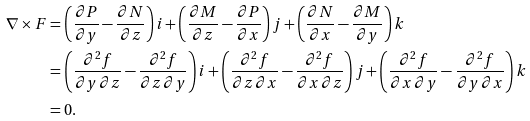<formula> <loc_0><loc_0><loc_500><loc_500>\nabla \times F & = \left ( \frac { \partial P } { \partial y } - \frac { \partial N } { \partial z } \right ) i + \left ( \frac { \partial M } { \partial z } - \frac { \partial P } { \partial x } \right ) j + \left ( \frac { \partial N } { \partial x } - \frac { \partial M } { \partial y } \right ) k \\ & = \left ( \frac { \partial ^ { 2 } f } { \partial y \, \partial z } - \frac { \partial ^ { 2 } f } { \partial z \, \partial y } \right ) i + \left ( \frac { \partial ^ { 2 } f } { \partial z \, \partial x } - \frac { \partial ^ { 2 } f } { \partial x \, \partial z } \right ) j + \left ( \frac { \partial ^ { 2 } f } { \partial x \, \partial y } - \frac { \partial ^ { 2 } f } { \partial y \, \partial x } \right ) k \\ & = 0 .</formula> 